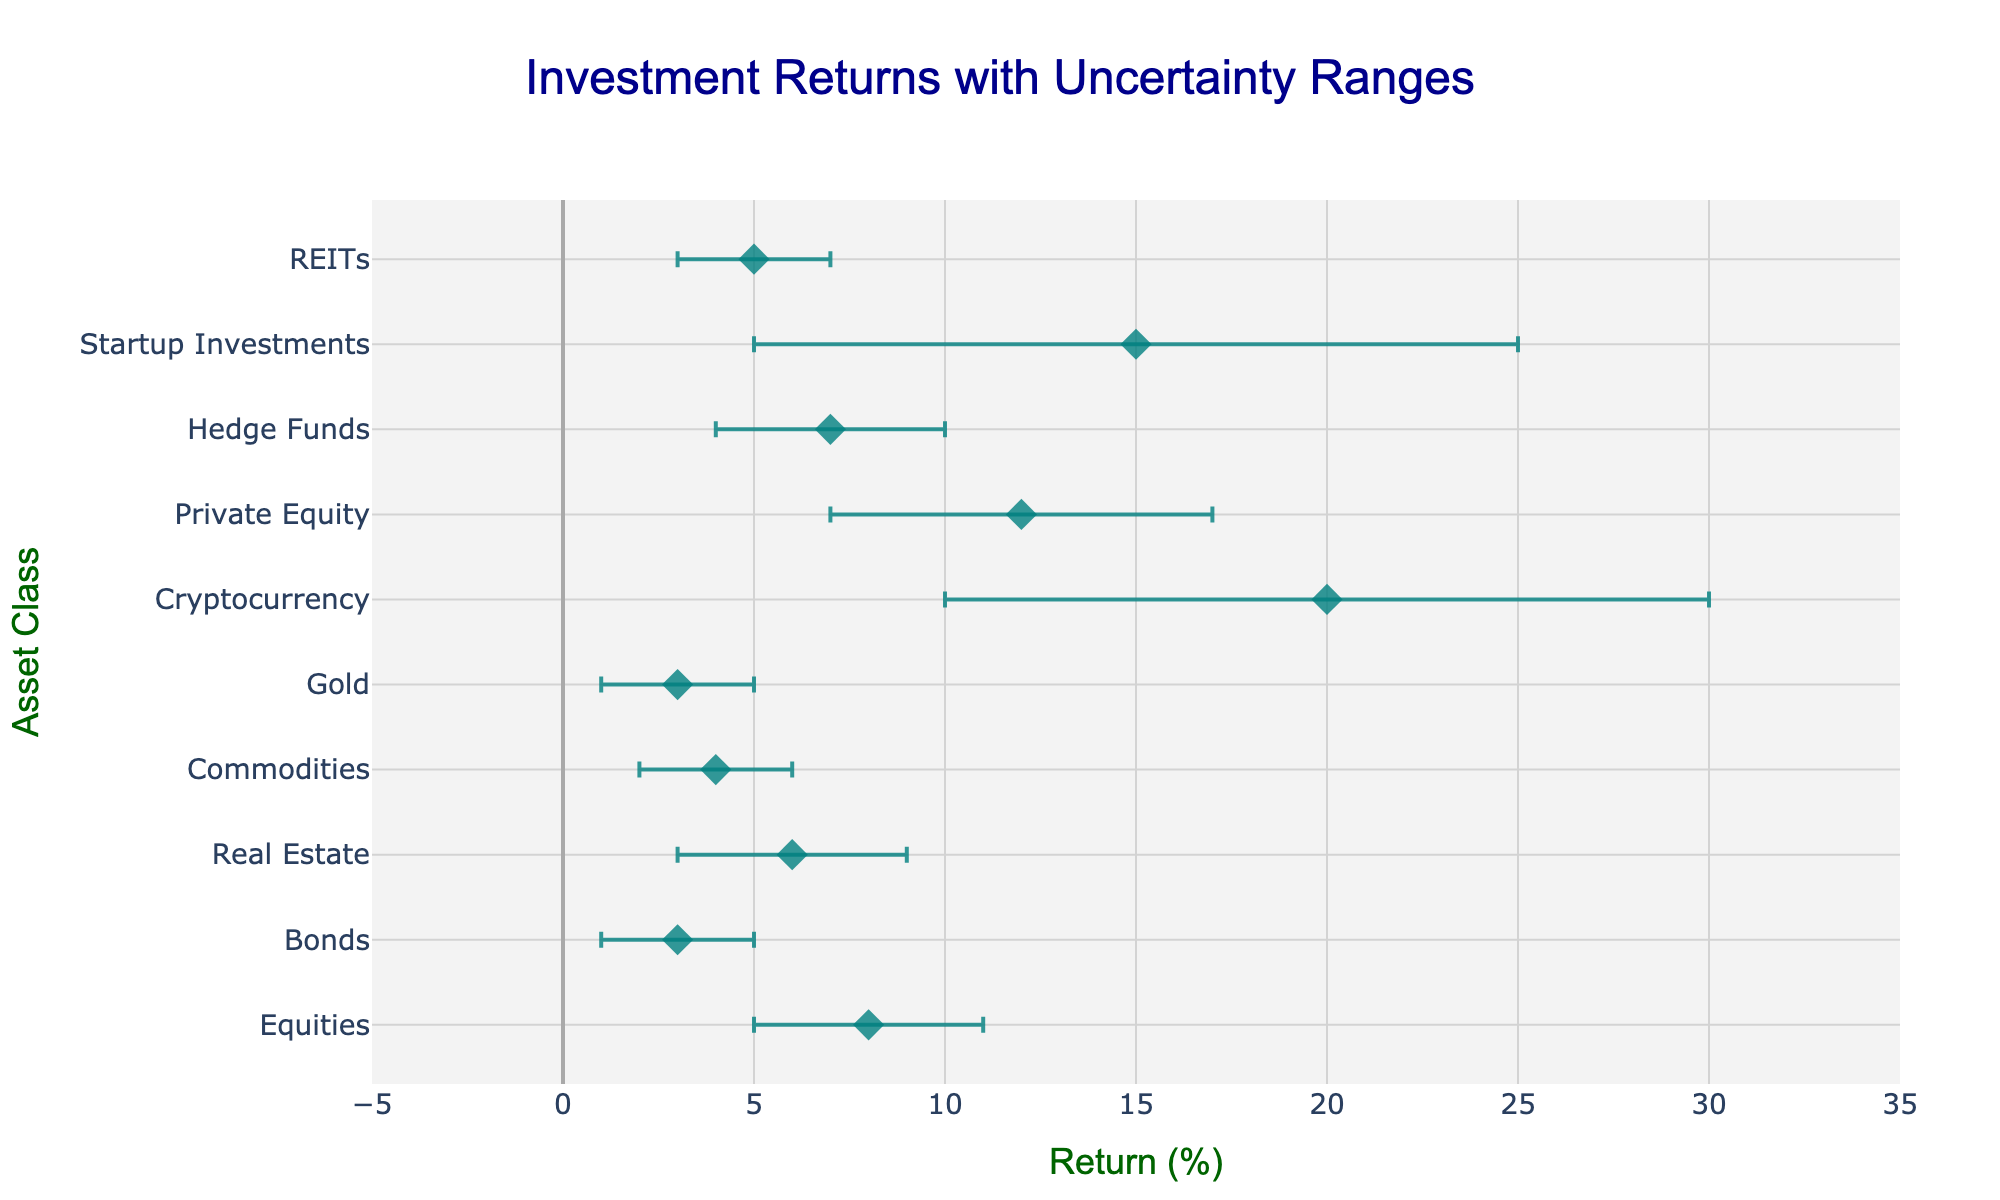what is the title of the plot? The title of a plot is usually located at the top and describes what the plot is about. In this case, the title is 'Investment Returns with Uncertainty Ranges'.
Answer: Investment Returns with Uncertainty Ranges What is the mean return (%) for Equities? The mean return for each asset class is directly labeled next to the asset class's marker on the x-axis. For Equities, the labeled mean return is 8%.
Answer: 8% Which asset class has the highest mean return? By comparing the mean return values labeled for each asset class marker, Cryptocurrency has the highest mean return of 20%.
Answer: Cryptocurrency How do the uncertainty ranges compare between Real Estate and Bonds? The uncertainty range can be determined by the error bars around the mean return. Real Estate has a range from 3% to 9% (6%), while Bonds range from 1% to 5% (4%).
Answer: Real Estate has a wider uncertainty range compared to Bonds What is the mean return difference between Private Equity and Hedge Funds? Subtract the mean return of Hedge Funds (7%) from the mean return of Private Equity (12%). So, 12% - 7% = 5%.
Answer: 5% Which asset class has the largest uncertainty range? The uncertainty range for each asset class can be determined by subtracting the lower bound from the upper bound. Cryptocurrency has the largest range: 30% - 10% = 20%.
Answer: Cryptocurrency How many asset classes have a mean return below 8%? By counting the asset classes with mean returns less than 8%, we find: Bonds (3%), Gold (3%), Commodities (4%), Real Estate (6%), Hedge Funds (7%), and REITs (5%). That makes 6 asset classes.
Answer: 6 Which asset classes share the same uncertainty range? By comparing the uncertainty ranges (difference between upper and lower bounds) for each asset class, Bonds and Gold both share the same range of 4% (5%-1% for Bonds, 5%-1% for Gold).
Answer: Bonds and Gold 